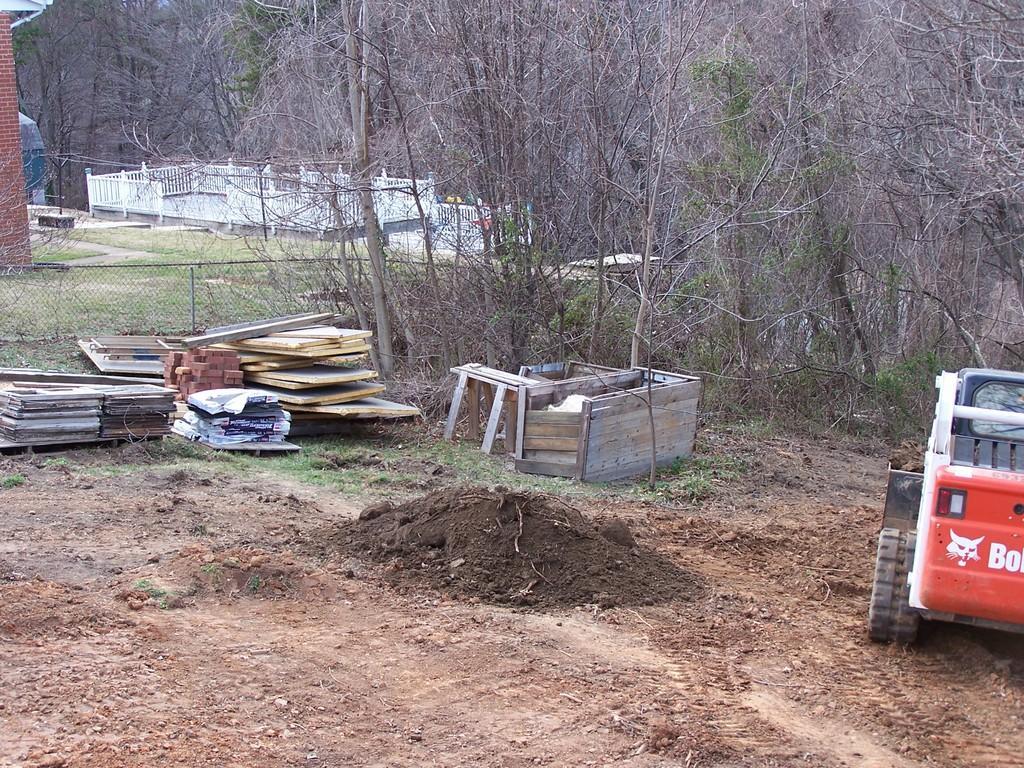In one or two sentences, can you explain what this image depicts? In this picture I can see trees and I can see a house on the top left side and I can see wooden planks on the ground and a vehicle on the right side and looks like another house in the back. 